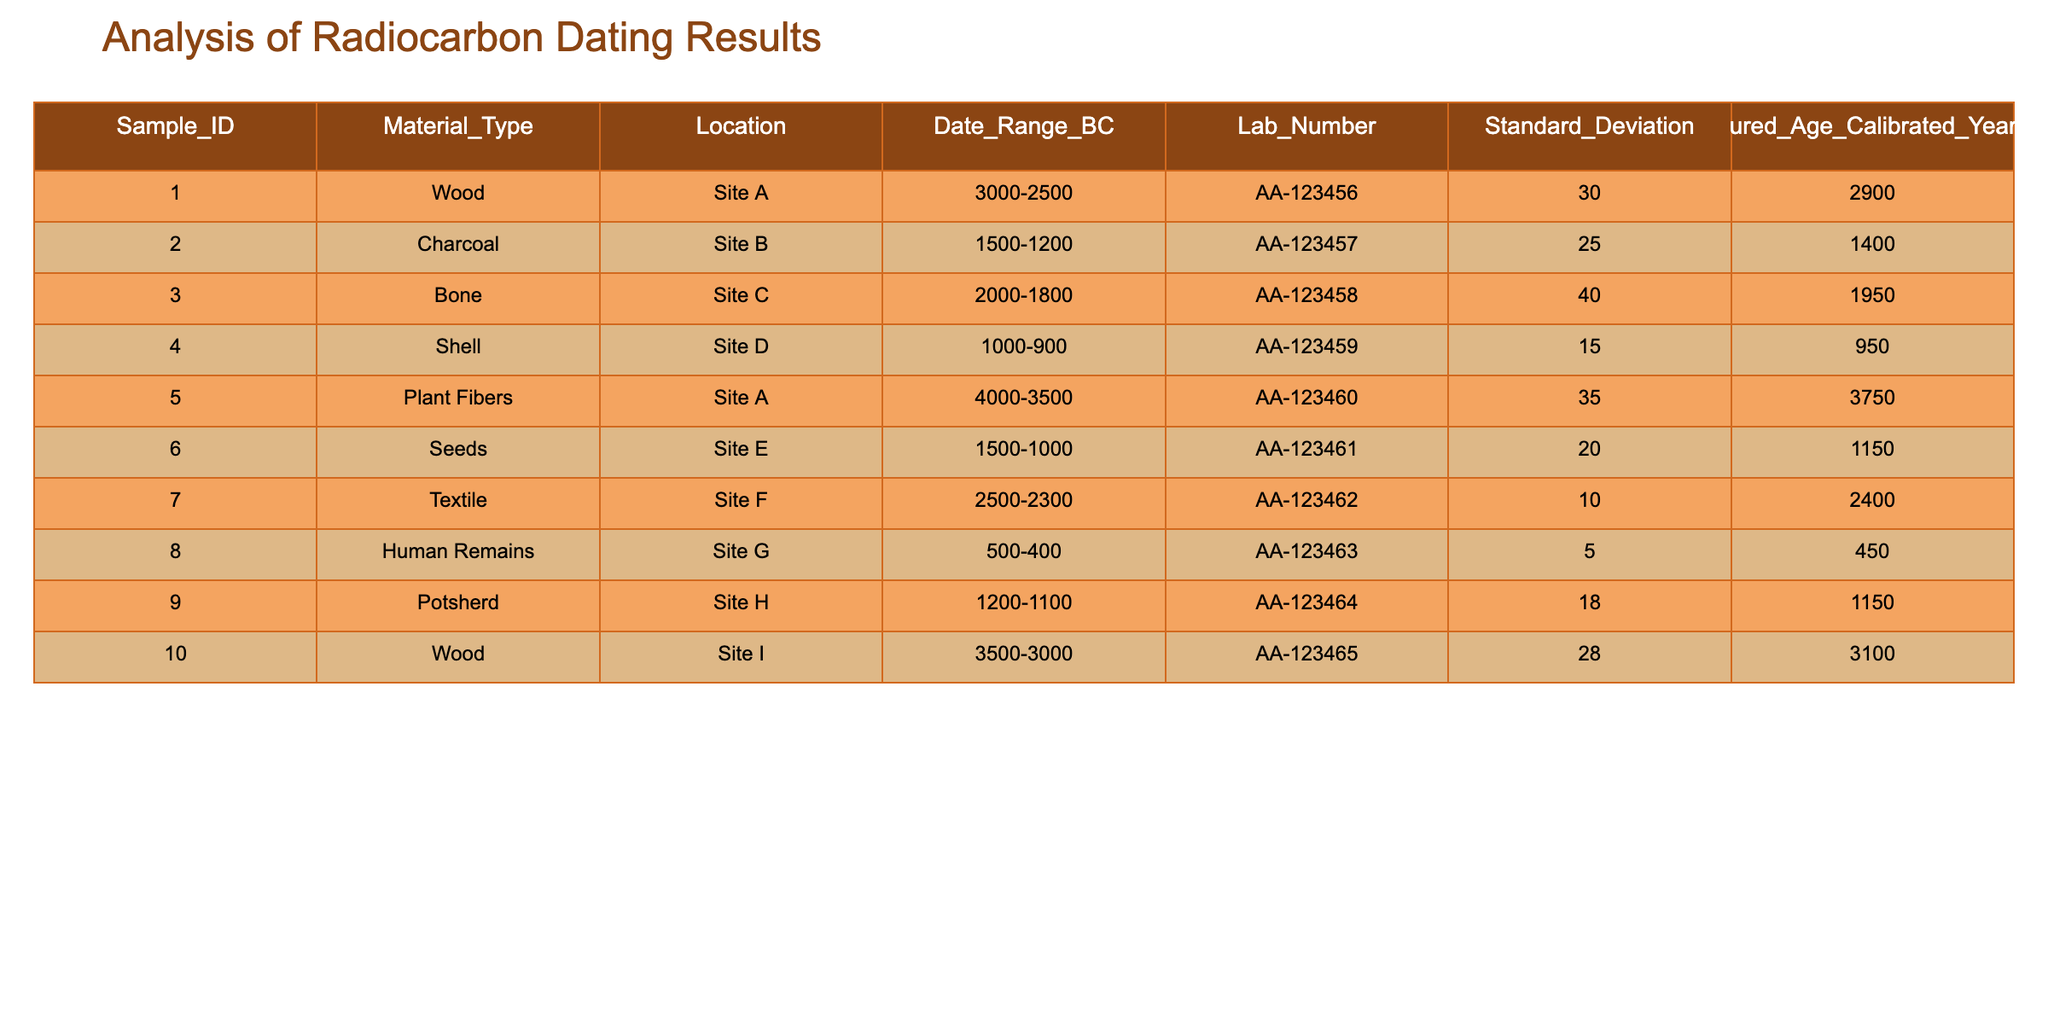What is the measured age of the sample from Site D? From the table, we look at the row for Site D, which corresponds to sample number 4. The column "Measured_Age_Calibrated_Years_BP" shows the value for this sample as 950.
Answer: 950 Which sample type has the earliest date range? To find the earliest date range, we compare the "Date_Range_BC" column for each sample. The earliest range is "4000-3500" associated with the "Plant Fibers" sample from Site A (sample number 5).
Answer: Plant Fibers What is the average standard deviation of all samples? We first identify the standard deviation values from the "Standard_Deviation" column: 30, 25, 40, 15, 35, 20, 10, 5, 18, 28. The sum is 28+18+5+10+35+20+15+40+25+30 = 226. There are 10 samples, so the average standard deviation is 226/10 = 22.6.
Answer: 22.6 Is there a sample from Site I with a measured age greater than 3000 BP? We check the "Measured_Age_Calibrated_Years_BP" for Site I (sample number 10). The measured age is 3100, which is greater than 3000, thus confirming the statement as true.
Answer: Yes Which material type has the highest measured age, and what is that age? Looking through the "Measured_Age_Calibrated_Years_BP" column, we find that the highest value is for the "Wood" sample from Site I, which has a measured age of 3100 years BP.
Answer: Wood, 3100 How many samples have a date range that overlaps with the range of 1500-1000 BC? We check the "Date_Range_BC" for each sample and find that samples from Site B (1500-1200), E (1500-1000), and C (2000-1800) all overlap with the specified range. That gives us a total of three samples.
Answer: 3 What is the difference between the maximum and minimum measured age in the table? First, we find the maximum measured age, which is 3100 (from Site I), and the minimum measured age, which is 450 (from Site G). The difference is 3100 - 450 = 2650.
Answer: 2650 Are all materials represented in the table from the same site? By examining the "Location" column, we see that multiple locations (Site A, B, C, etc.) are represented. Thus, the statement is false, as the samples come from different sites.
Answer: No 